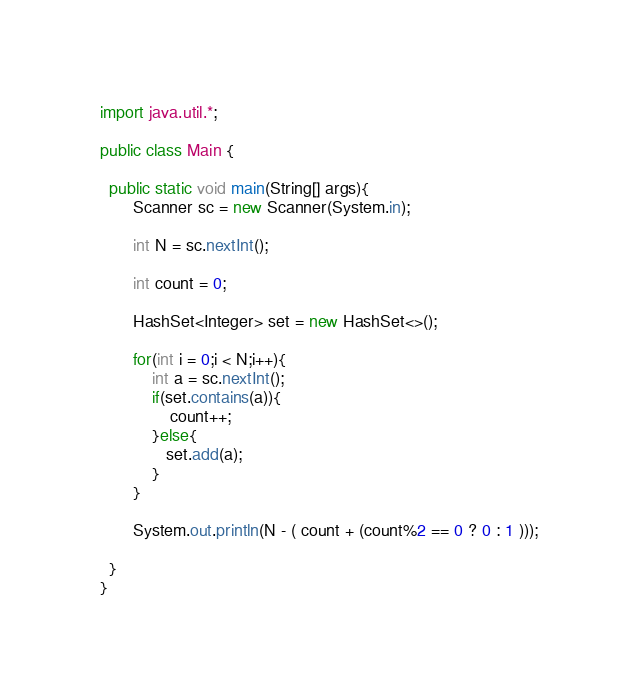<code> <loc_0><loc_0><loc_500><loc_500><_Java_>import java.util.*;

public class Main {
        
  public static void main(String[] args){
       Scanner sc = new Scanner(System.in);
   
       int N = sc.nextInt();
      
       int count = 0;
       
       HashSet<Integer> set = new HashSet<>();
       
       for(int i = 0;i < N;i++){
           int a = sc.nextInt();
           if(set.contains(a)){
               count++;
           }else{
              set.add(a);
           }
       }
              
       System.out.println(N - ( count + (count%2 == 0 ? 0 : 1 )));

  }  
}

</code> 